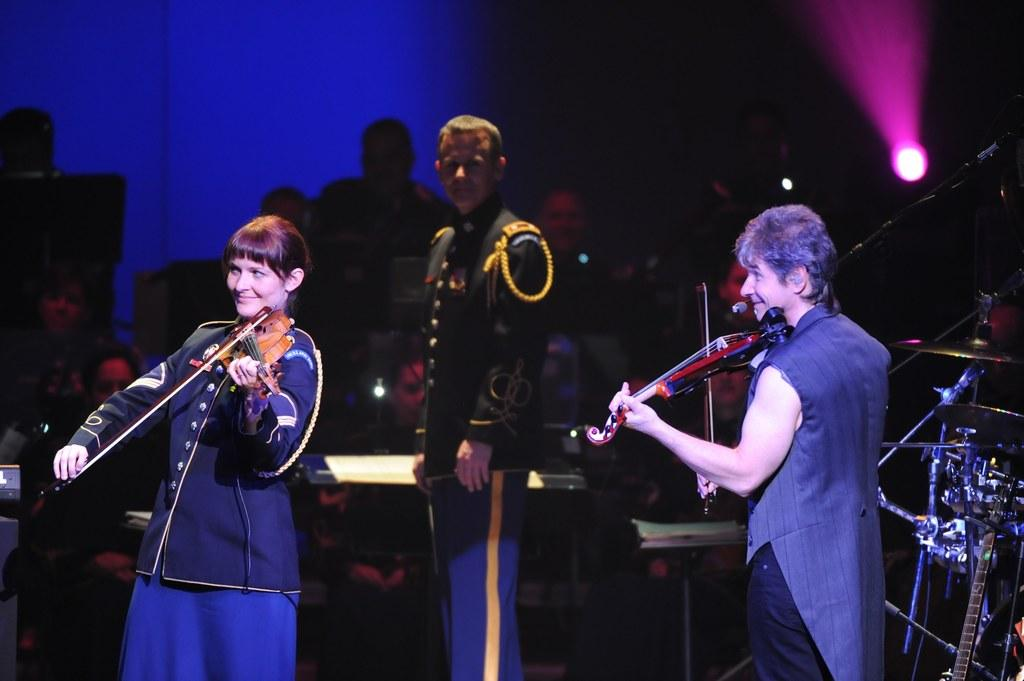Who or what is present in the image? There are people in the image. What are the people doing in the image? The people are playing musical instruments. What type of pest can be seen crawling on the musical instruments in the image? There are no pests visible in the image; the people are playing musical instruments without any interference. 